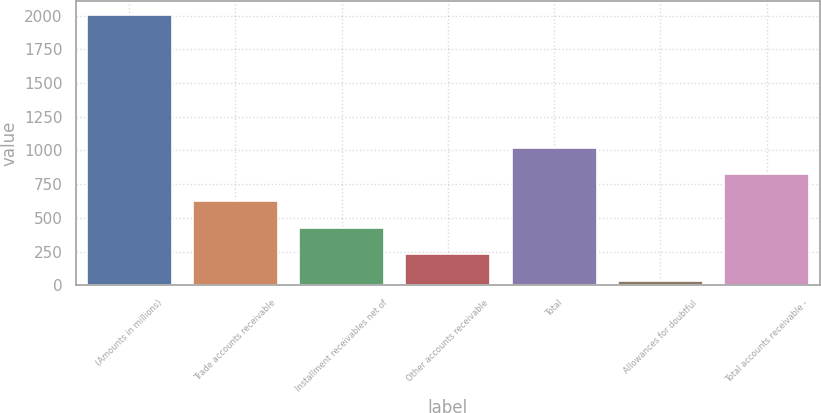Convert chart. <chart><loc_0><loc_0><loc_500><loc_500><bar_chart><fcel>(Amounts in millions)<fcel>Trade accounts receivable<fcel>Installment receivables net of<fcel>Other accounts receivable<fcel>Total<fcel>Allowances for doubtful<fcel>Total accounts receivable -<nl><fcel>2006<fcel>624.83<fcel>427.52<fcel>230.21<fcel>1019.45<fcel>32.9<fcel>822.14<nl></chart> 